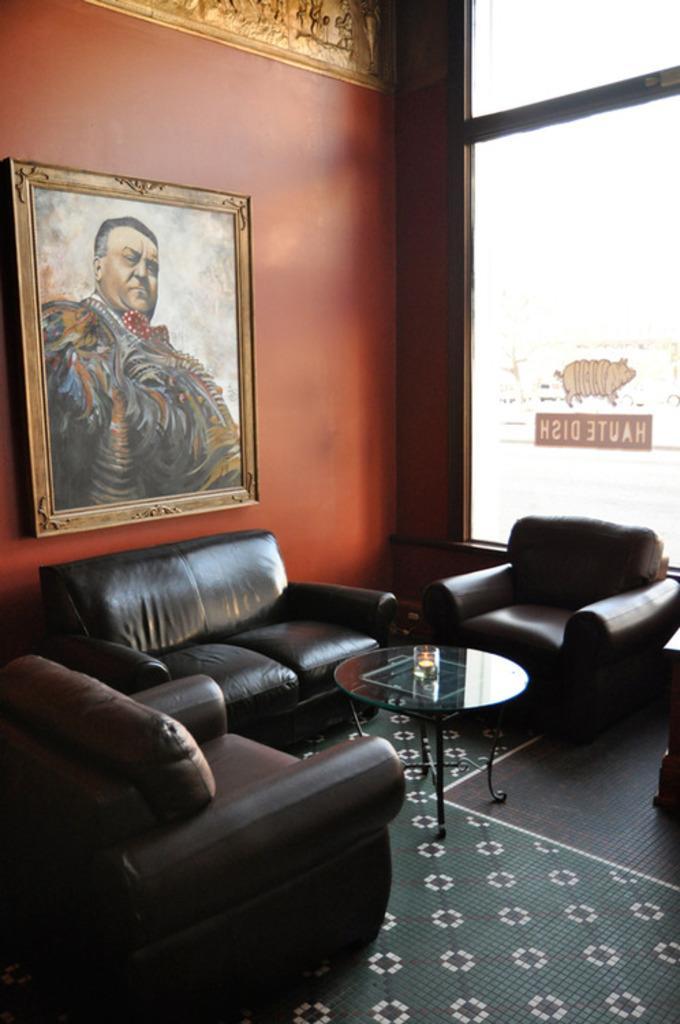Please provide a concise description of this image. In this image there is a frame attached to a wall, couch, chair, carpet, table , glass and the back ground there is sculpture, and a sticker attached to a building. 